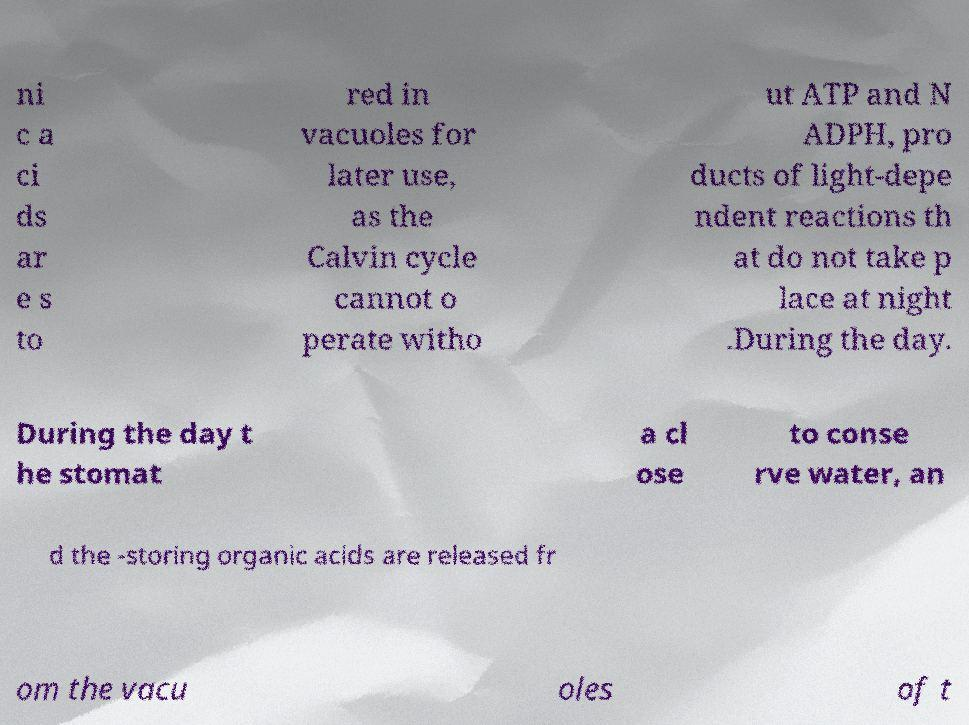I need the written content from this picture converted into text. Can you do that? ni c a ci ds ar e s to red in vacuoles for later use, as the Calvin cycle cannot o perate witho ut ATP and N ADPH, pro ducts of light-depe ndent reactions th at do not take p lace at night .During the day. During the day t he stomat a cl ose to conse rve water, an d the -storing organic acids are released fr om the vacu oles of t 